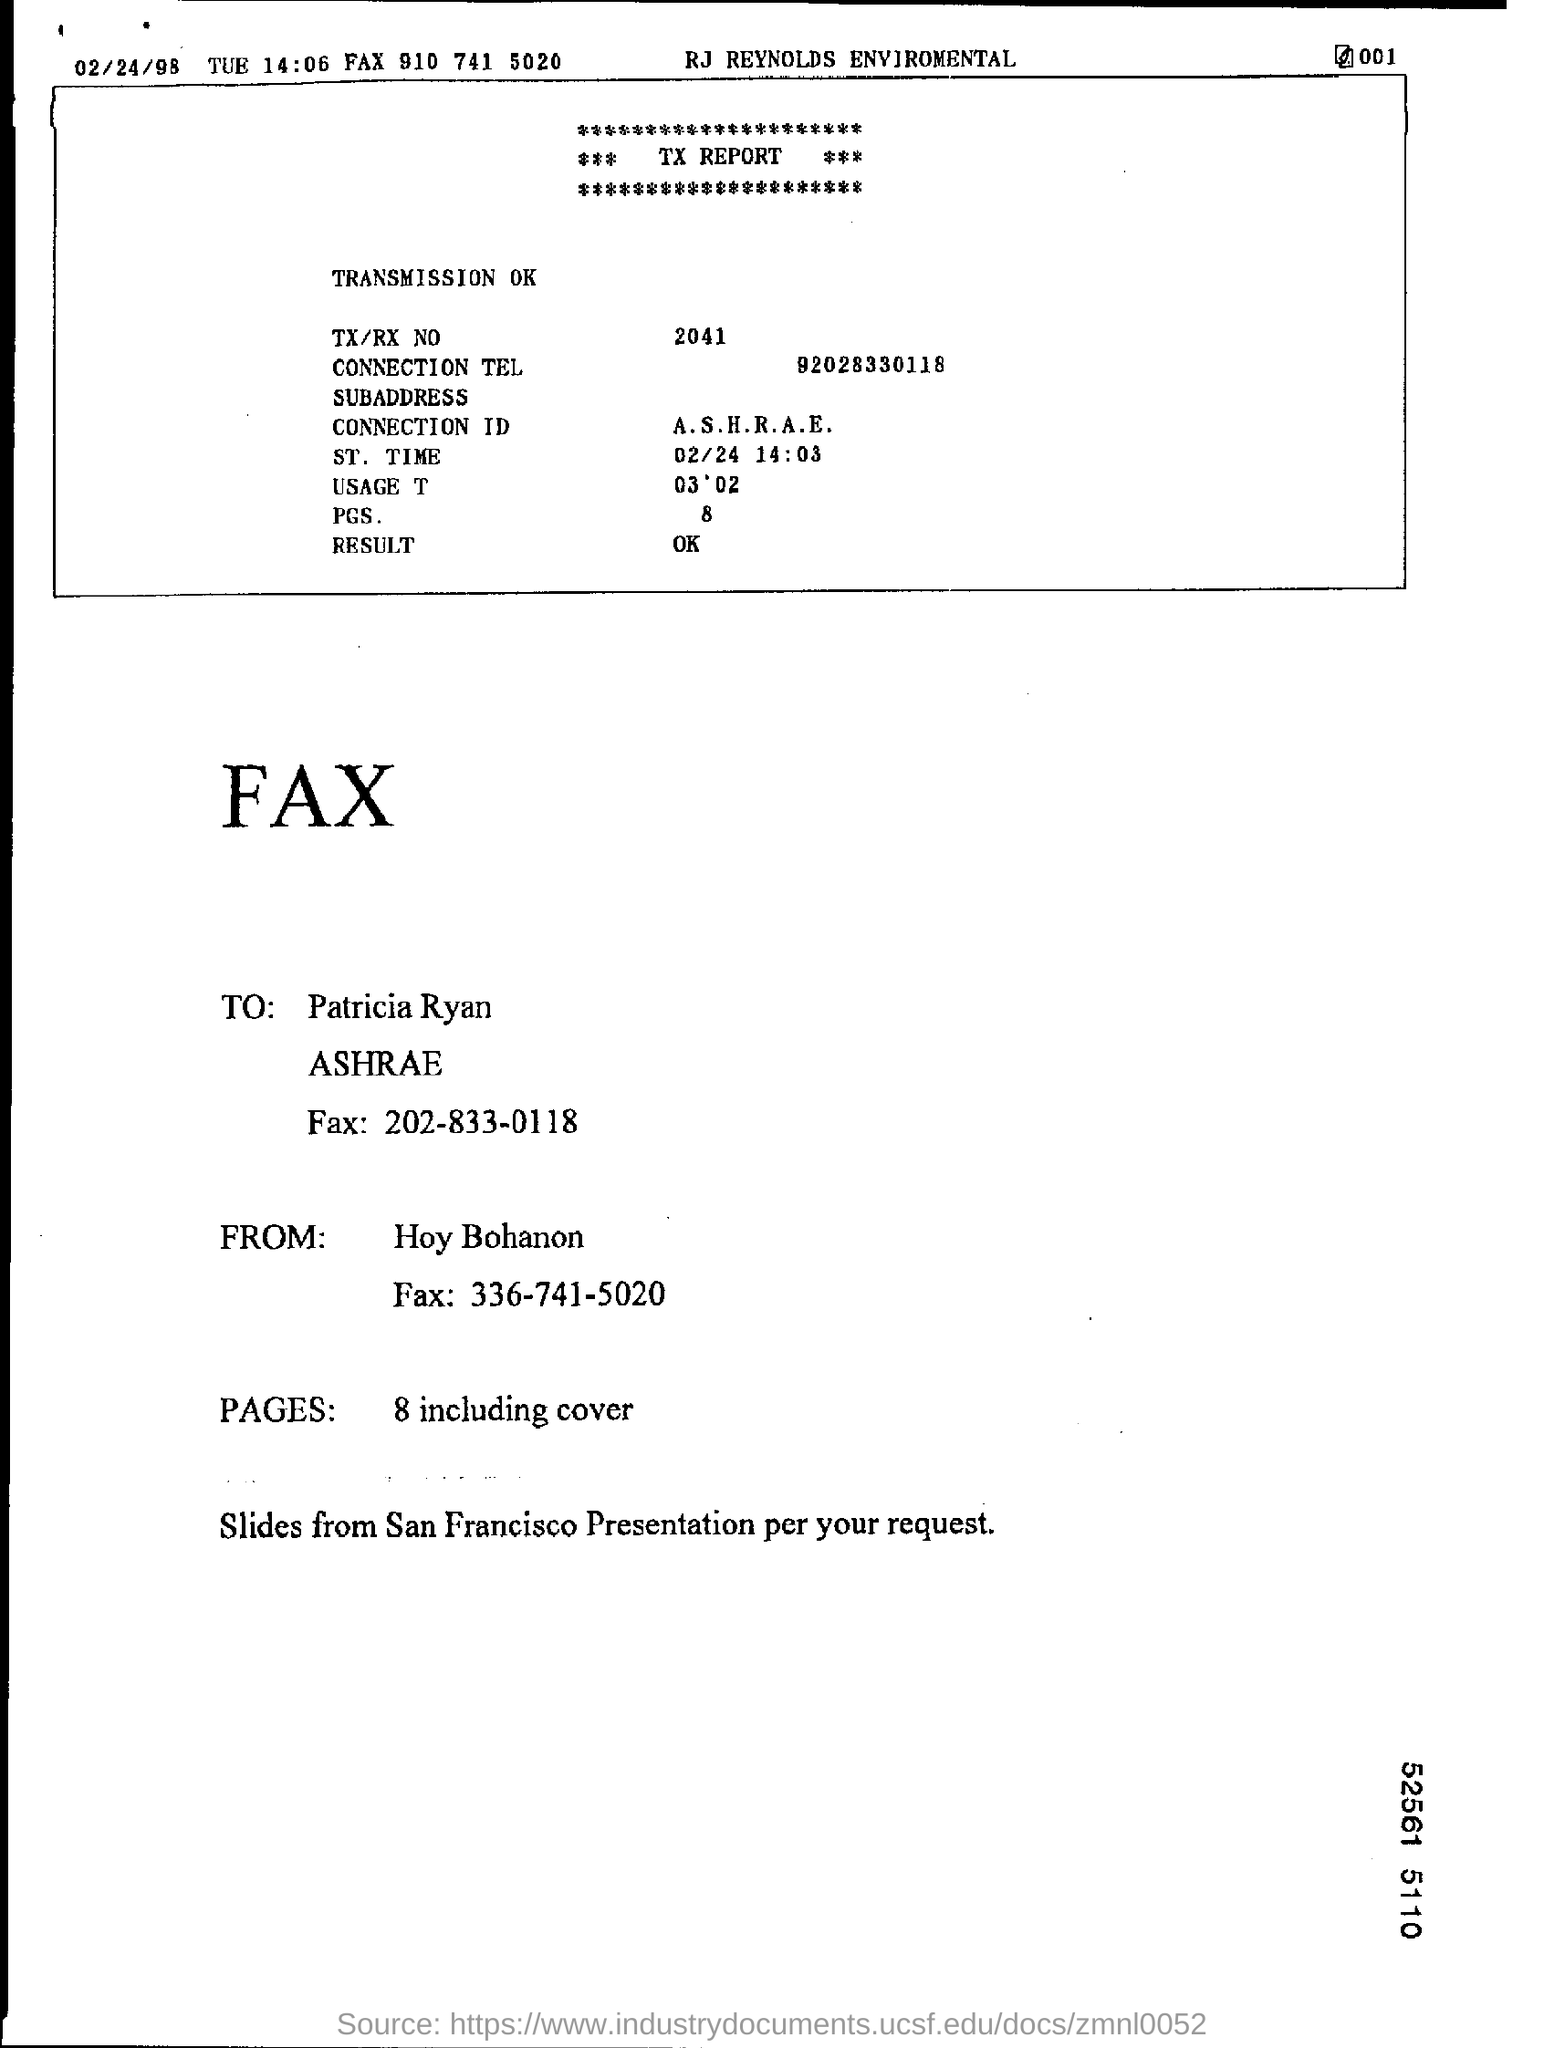What is the ST. Time? The Standard Time (ST) indicated in the fax document is 02/24 at 14:03. This represents the timestamp at which the transaction or operation referenced was noted or effective. 